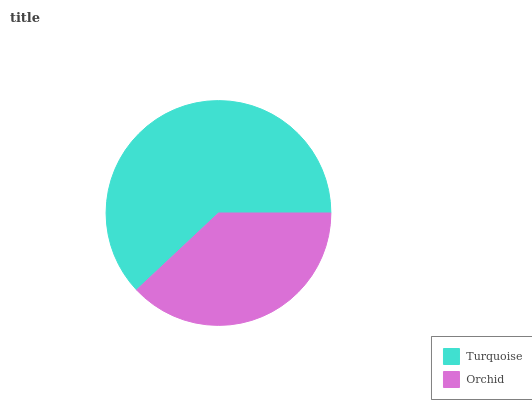Is Orchid the minimum?
Answer yes or no. Yes. Is Turquoise the maximum?
Answer yes or no. Yes. Is Orchid the maximum?
Answer yes or no. No. Is Turquoise greater than Orchid?
Answer yes or no. Yes. Is Orchid less than Turquoise?
Answer yes or no. Yes. Is Orchid greater than Turquoise?
Answer yes or no. No. Is Turquoise less than Orchid?
Answer yes or no. No. Is Turquoise the high median?
Answer yes or no. Yes. Is Orchid the low median?
Answer yes or no. Yes. Is Orchid the high median?
Answer yes or no. No. Is Turquoise the low median?
Answer yes or no. No. 